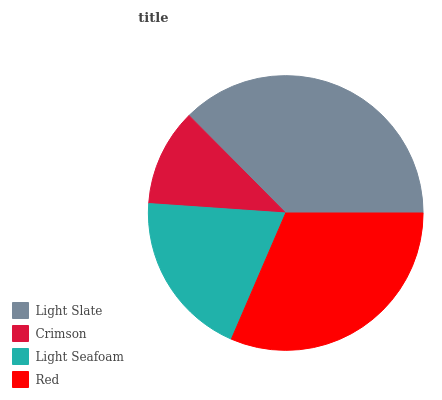Is Crimson the minimum?
Answer yes or no. Yes. Is Light Slate the maximum?
Answer yes or no. Yes. Is Light Seafoam the minimum?
Answer yes or no. No. Is Light Seafoam the maximum?
Answer yes or no. No. Is Light Seafoam greater than Crimson?
Answer yes or no. Yes. Is Crimson less than Light Seafoam?
Answer yes or no. Yes. Is Crimson greater than Light Seafoam?
Answer yes or no. No. Is Light Seafoam less than Crimson?
Answer yes or no. No. Is Red the high median?
Answer yes or no. Yes. Is Light Seafoam the low median?
Answer yes or no. Yes. Is Light Seafoam the high median?
Answer yes or no. No. Is Red the low median?
Answer yes or no. No. 